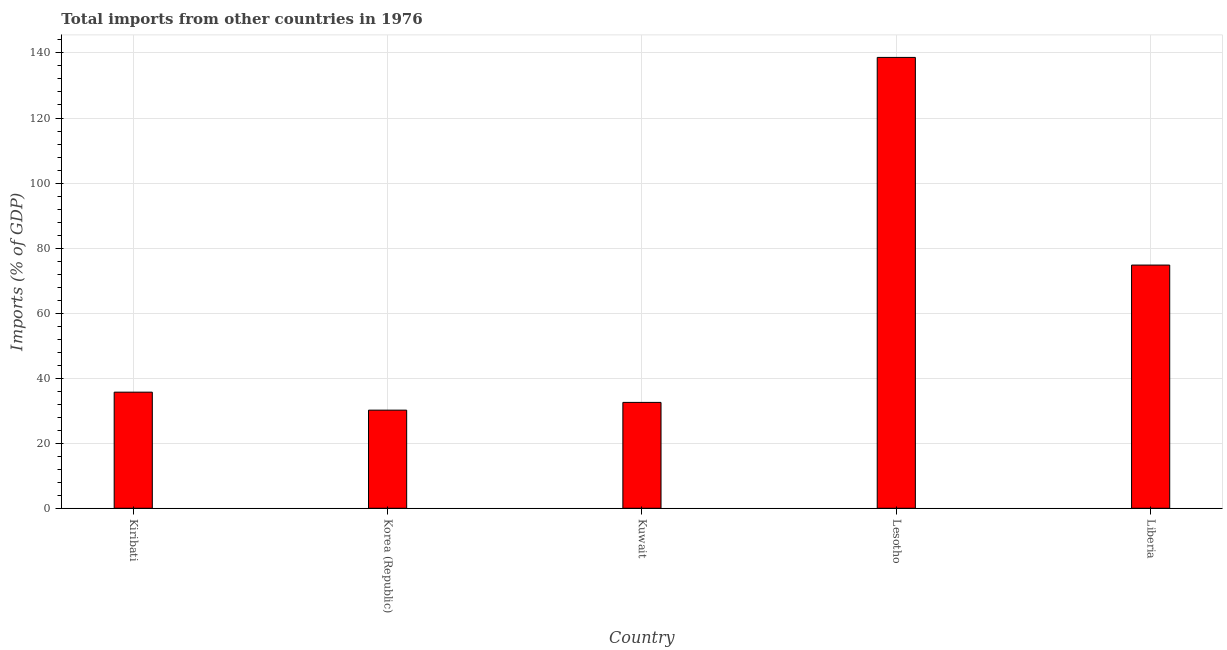Does the graph contain any zero values?
Your answer should be very brief. No. Does the graph contain grids?
Offer a terse response. Yes. What is the title of the graph?
Offer a very short reply. Total imports from other countries in 1976. What is the label or title of the Y-axis?
Offer a very short reply. Imports (% of GDP). What is the total imports in Lesotho?
Offer a terse response. 138.63. Across all countries, what is the maximum total imports?
Your answer should be very brief. 138.63. Across all countries, what is the minimum total imports?
Your response must be concise. 30.17. In which country was the total imports maximum?
Make the answer very short. Lesotho. In which country was the total imports minimum?
Keep it short and to the point. Korea (Republic). What is the sum of the total imports?
Offer a terse response. 311.84. What is the difference between the total imports in Korea (Republic) and Kuwait?
Your response must be concise. -2.38. What is the average total imports per country?
Your response must be concise. 62.37. What is the median total imports?
Your response must be concise. 35.7. In how many countries, is the total imports greater than 4 %?
Offer a terse response. 5. What is the ratio of the total imports in Korea (Republic) to that in Lesotho?
Your answer should be very brief. 0.22. Is the difference between the total imports in Korea (Republic) and Lesotho greater than the difference between any two countries?
Provide a succinct answer. Yes. What is the difference between the highest and the second highest total imports?
Offer a terse response. 63.85. Is the sum of the total imports in Kiribati and Lesotho greater than the maximum total imports across all countries?
Keep it short and to the point. Yes. What is the difference between the highest and the lowest total imports?
Your response must be concise. 108.46. How many bars are there?
Your answer should be compact. 5. How many countries are there in the graph?
Your answer should be very brief. 5. Are the values on the major ticks of Y-axis written in scientific E-notation?
Provide a succinct answer. No. What is the Imports (% of GDP) in Kiribati?
Keep it short and to the point. 35.7. What is the Imports (% of GDP) in Korea (Republic)?
Provide a succinct answer. 30.17. What is the Imports (% of GDP) of Kuwait?
Your response must be concise. 32.55. What is the Imports (% of GDP) of Lesotho?
Give a very brief answer. 138.63. What is the Imports (% of GDP) in Liberia?
Ensure brevity in your answer.  74.78. What is the difference between the Imports (% of GDP) in Kiribati and Korea (Republic)?
Your answer should be very brief. 5.53. What is the difference between the Imports (% of GDP) in Kiribati and Kuwait?
Offer a terse response. 3.15. What is the difference between the Imports (% of GDP) in Kiribati and Lesotho?
Offer a terse response. -102.93. What is the difference between the Imports (% of GDP) in Kiribati and Liberia?
Your response must be concise. -39.08. What is the difference between the Imports (% of GDP) in Korea (Republic) and Kuwait?
Your answer should be compact. -2.38. What is the difference between the Imports (% of GDP) in Korea (Republic) and Lesotho?
Your answer should be compact. -108.46. What is the difference between the Imports (% of GDP) in Korea (Republic) and Liberia?
Ensure brevity in your answer.  -44.61. What is the difference between the Imports (% of GDP) in Kuwait and Lesotho?
Provide a short and direct response. -106.07. What is the difference between the Imports (% of GDP) in Kuwait and Liberia?
Provide a succinct answer. -42.23. What is the difference between the Imports (% of GDP) in Lesotho and Liberia?
Give a very brief answer. 63.85. What is the ratio of the Imports (% of GDP) in Kiribati to that in Korea (Republic)?
Your response must be concise. 1.18. What is the ratio of the Imports (% of GDP) in Kiribati to that in Kuwait?
Make the answer very short. 1.1. What is the ratio of the Imports (% of GDP) in Kiribati to that in Lesotho?
Your response must be concise. 0.26. What is the ratio of the Imports (% of GDP) in Kiribati to that in Liberia?
Your answer should be compact. 0.48. What is the ratio of the Imports (% of GDP) in Korea (Republic) to that in Kuwait?
Your answer should be very brief. 0.93. What is the ratio of the Imports (% of GDP) in Korea (Republic) to that in Lesotho?
Ensure brevity in your answer.  0.22. What is the ratio of the Imports (% of GDP) in Korea (Republic) to that in Liberia?
Give a very brief answer. 0.4. What is the ratio of the Imports (% of GDP) in Kuwait to that in Lesotho?
Provide a succinct answer. 0.23. What is the ratio of the Imports (% of GDP) in Kuwait to that in Liberia?
Provide a short and direct response. 0.43. What is the ratio of the Imports (% of GDP) in Lesotho to that in Liberia?
Your response must be concise. 1.85. 